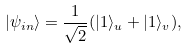<formula> <loc_0><loc_0><loc_500><loc_500>| \psi _ { i n } \rangle = \frac { 1 } { \sqrt { 2 } } ( | 1 \rangle _ { u } + | 1 \rangle _ { v } ) ,</formula> 